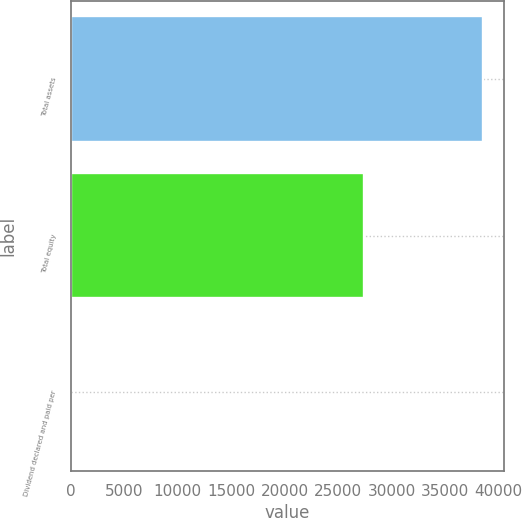Convert chart to OTSL. <chart><loc_0><loc_0><loc_500><loc_500><bar_chart><fcel>Total assets<fcel>Total equity<fcel>Dividend declared and paid per<nl><fcel>38569<fcel>27413<fcel>1.6<nl></chart> 